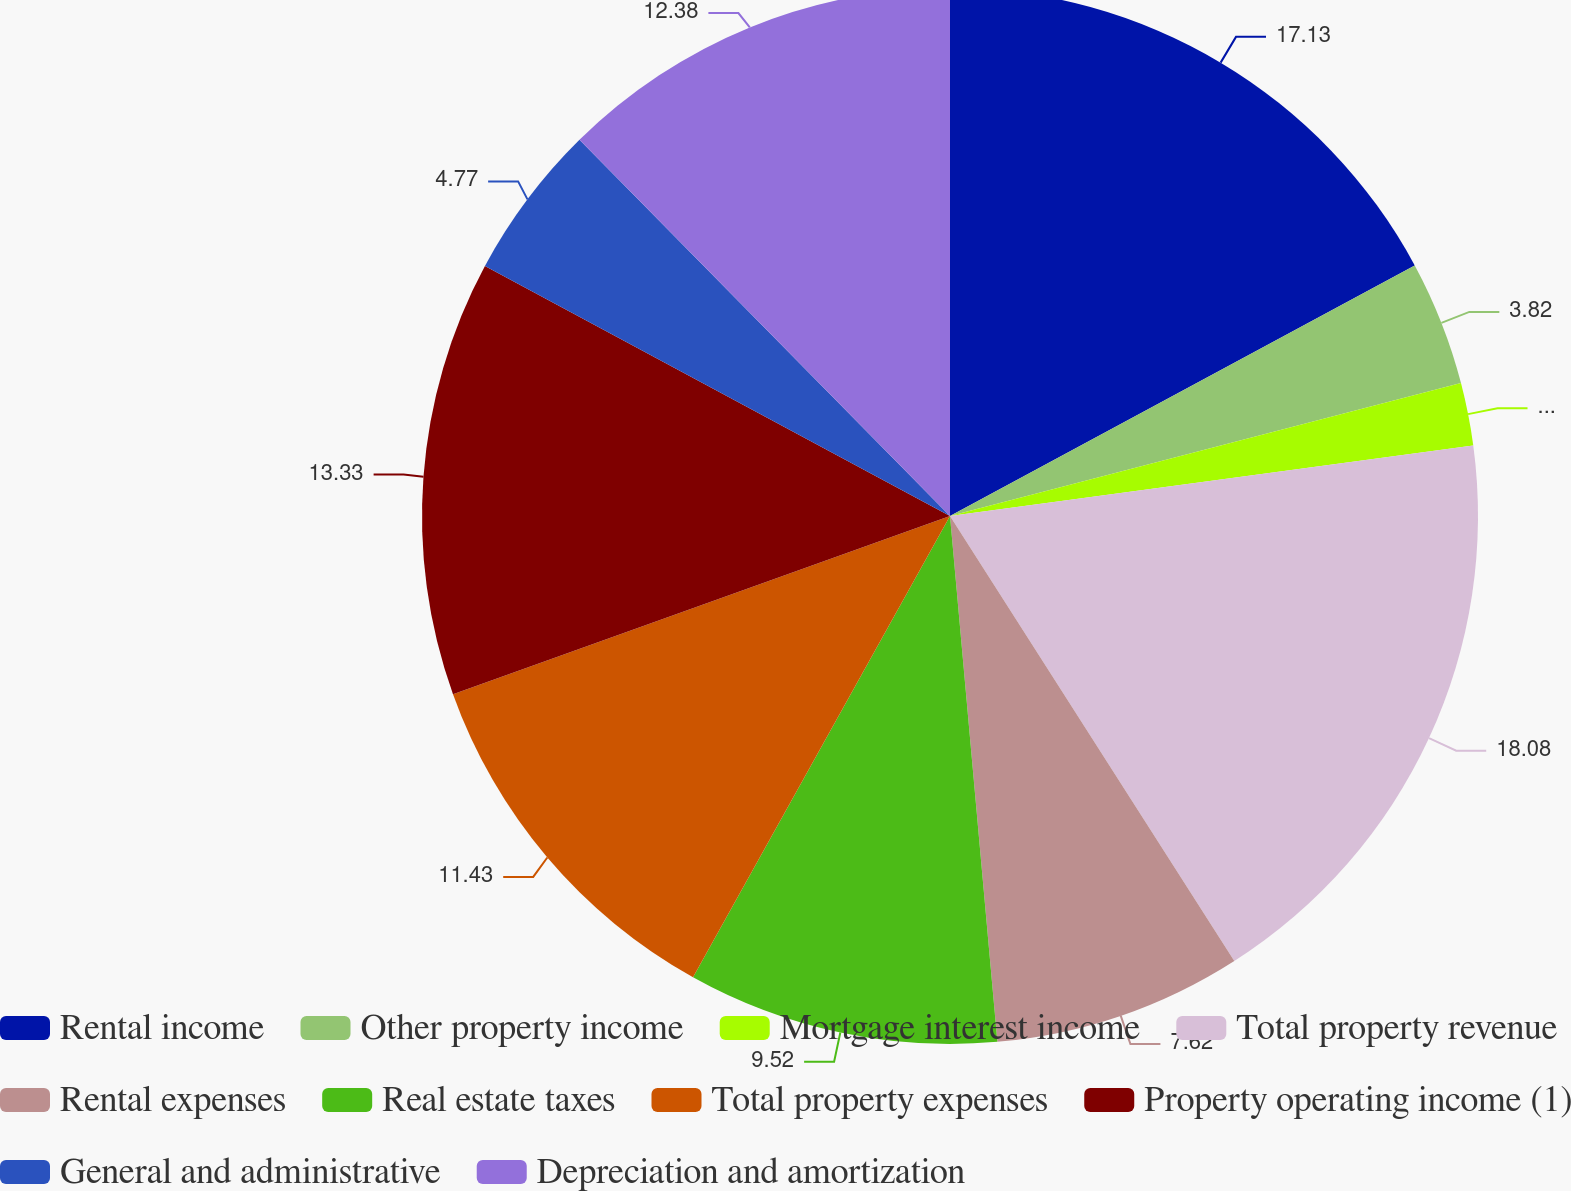Convert chart to OTSL. <chart><loc_0><loc_0><loc_500><loc_500><pie_chart><fcel>Rental income<fcel>Other property income<fcel>Mortgage interest income<fcel>Total property revenue<fcel>Rental expenses<fcel>Real estate taxes<fcel>Total property expenses<fcel>Property operating income (1)<fcel>General and administrative<fcel>Depreciation and amortization<nl><fcel>17.13%<fcel>3.82%<fcel>1.92%<fcel>18.08%<fcel>7.62%<fcel>9.52%<fcel>11.43%<fcel>13.33%<fcel>4.77%<fcel>12.38%<nl></chart> 